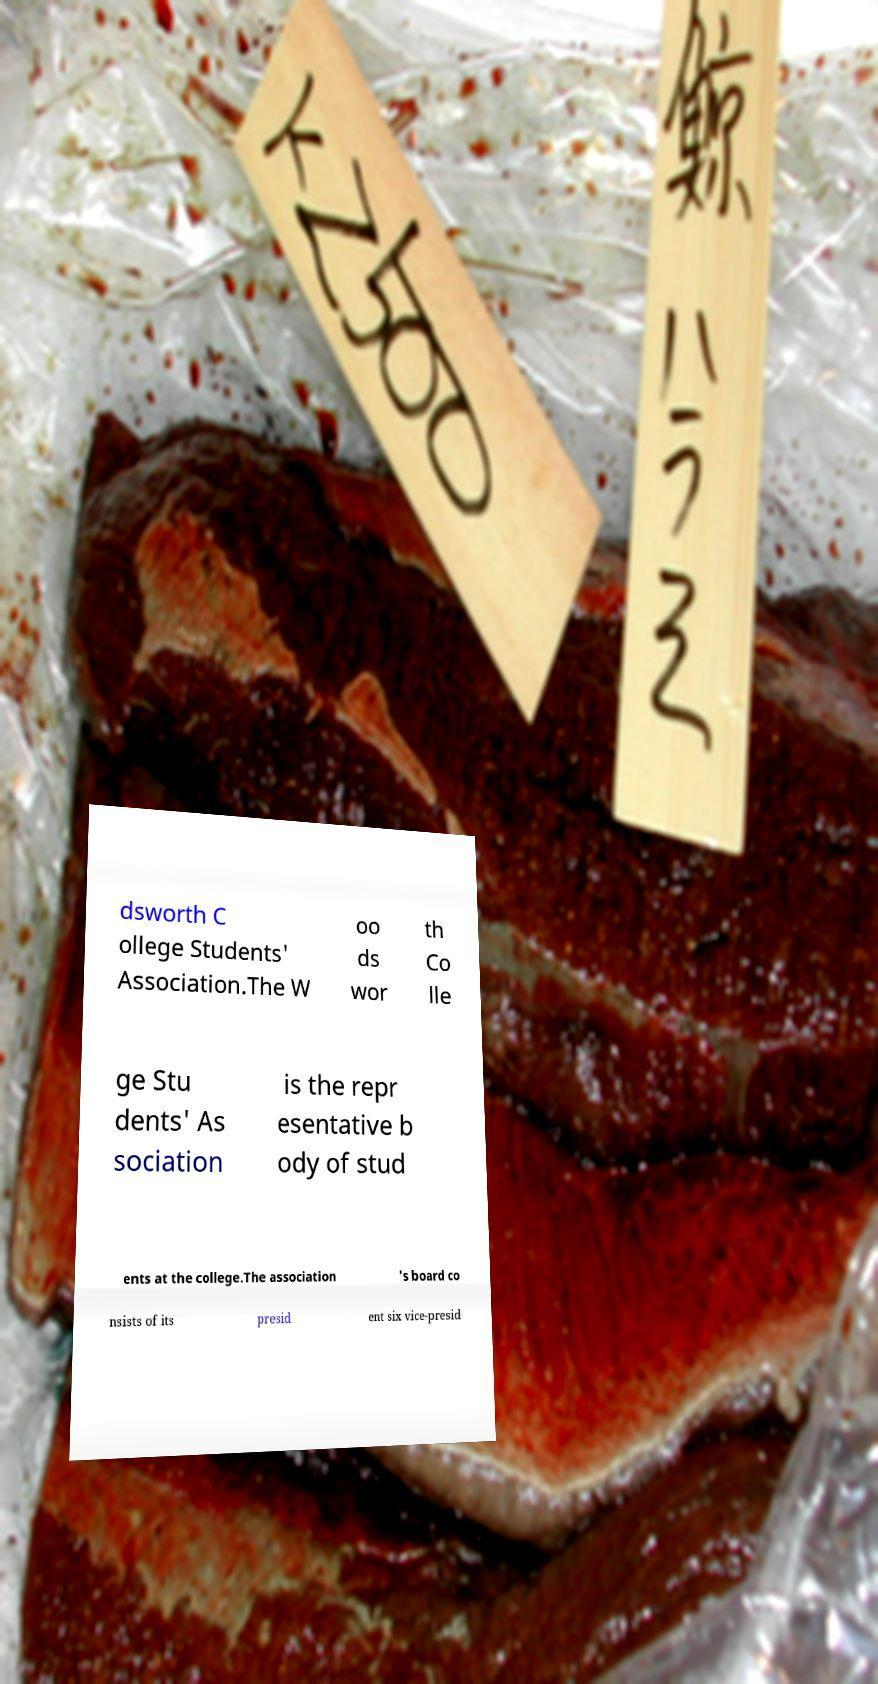Please read and relay the text visible in this image. What does it say? dsworth C ollege Students' Association.The W oo ds wor th Co lle ge Stu dents' As sociation is the repr esentative b ody of stud ents at the college.The association 's board co nsists of its presid ent six vice-presid 